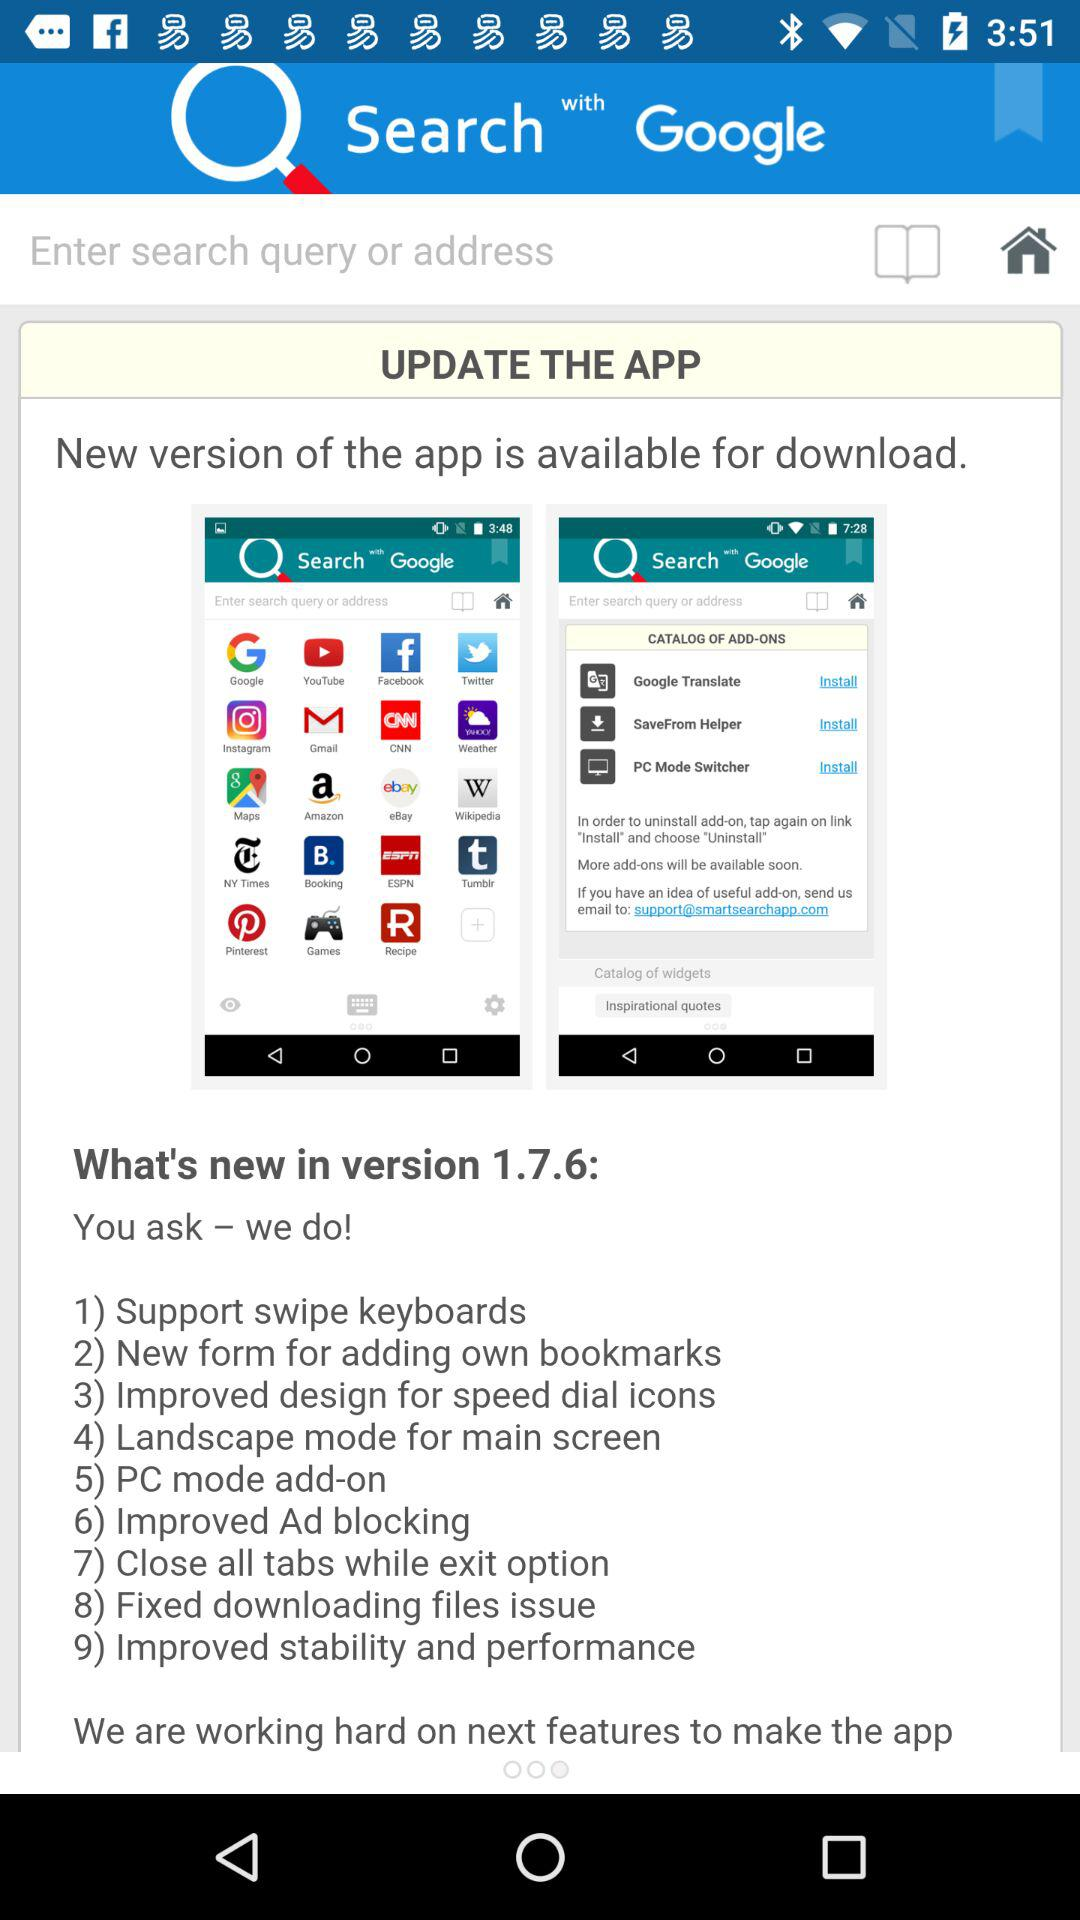What's new in version 1.7.6? In version 1.7.6, "Support swipe keyboards", "New form for adding own bookmarks", "Improved design for speed dial icons", "Landscape mode for main screen", "PC mode add-on", "Improved Ad blocking", "Close all tabs while exit option", "Fixed downloading files issue" and "Improved stability and performance" are new. 